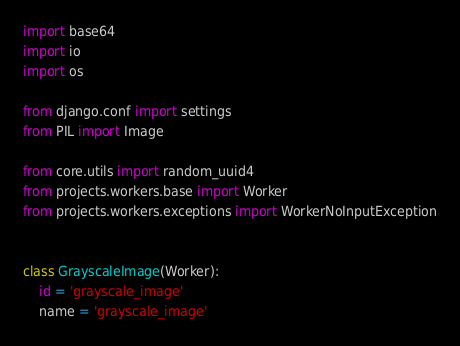<code> <loc_0><loc_0><loc_500><loc_500><_Python_>import base64
import io
import os

from django.conf import settings
from PIL import Image

from core.utils import random_uuid4
from projects.workers.base import Worker
from projects.workers.exceptions import WorkerNoInputException


class GrayscaleImage(Worker):
    id = 'grayscale_image'
    name = 'grayscale_image'</code> 